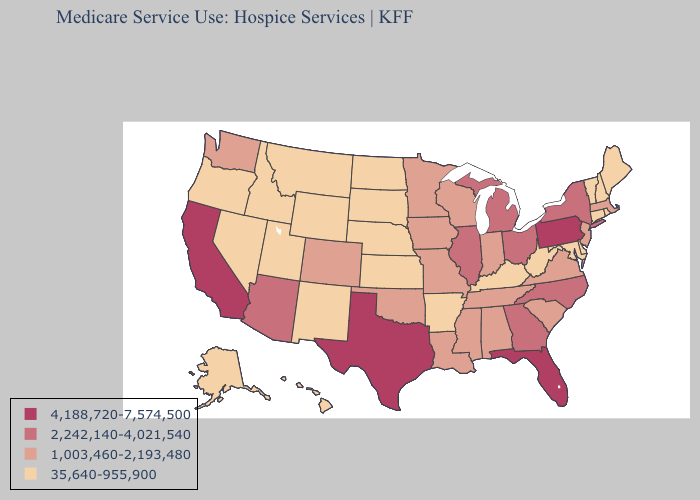How many symbols are there in the legend?
Write a very short answer. 4. Does Utah have the lowest value in the USA?
Give a very brief answer. Yes. Does Wisconsin have a lower value than Pennsylvania?
Concise answer only. Yes. Name the states that have a value in the range 4,188,720-7,574,500?
Give a very brief answer. California, Florida, Pennsylvania, Texas. Does Tennessee have the lowest value in the South?
Answer briefly. No. What is the value of Wisconsin?
Give a very brief answer. 1,003,460-2,193,480. Among the states that border Kansas , does Oklahoma have the lowest value?
Give a very brief answer. No. What is the value of Kansas?
Keep it brief. 35,640-955,900. Is the legend a continuous bar?
Be succinct. No. What is the value of Nevada?
Write a very short answer. 35,640-955,900. What is the value of Idaho?
Answer briefly. 35,640-955,900. What is the value of Maryland?
Answer briefly. 35,640-955,900. Name the states that have a value in the range 35,640-955,900?
Keep it brief. Alaska, Arkansas, Connecticut, Delaware, Hawaii, Idaho, Kansas, Kentucky, Maine, Maryland, Montana, Nebraska, Nevada, New Hampshire, New Mexico, North Dakota, Oregon, Rhode Island, South Dakota, Utah, Vermont, West Virginia, Wyoming. What is the highest value in the USA?
Write a very short answer. 4,188,720-7,574,500. What is the lowest value in the USA?
Give a very brief answer. 35,640-955,900. 